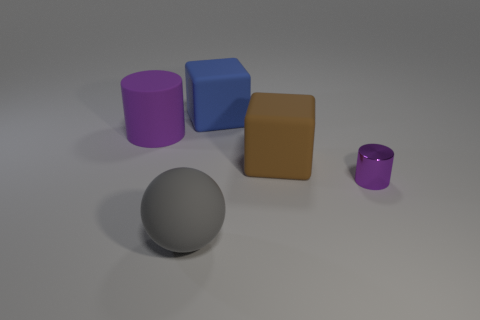How many other things are the same material as the big brown cube?
Offer a very short reply. 3. What shape is the purple thing that is behind the purple object in front of the purple cylinder that is left of the small shiny cylinder?
Provide a short and direct response. Cylinder. Are there fewer purple metallic things left of the gray ball than big cylinders in front of the tiny thing?
Provide a short and direct response. No. Are there any tiny cylinders that have the same color as the small metallic object?
Give a very brief answer. No. Is the material of the large purple cylinder the same as the purple object right of the blue thing?
Make the answer very short. No. Are there any matte cylinders that are in front of the big cube that is in front of the blue rubber cube?
Provide a short and direct response. No. There is a object that is in front of the big brown object and on the left side of the tiny purple cylinder; what color is it?
Your answer should be very brief. Gray. How big is the brown matte block?
Provide a succinct answer. Large. What number of brown rubber objects have the same size as the gray matte thing?
Your response must be concise. 1. Do the cylinder that is on the left side of the big gray matte object and the big gray sphere that is in front of the shiny cylinder have the same material?
Provide a short and direct response. Yes. 